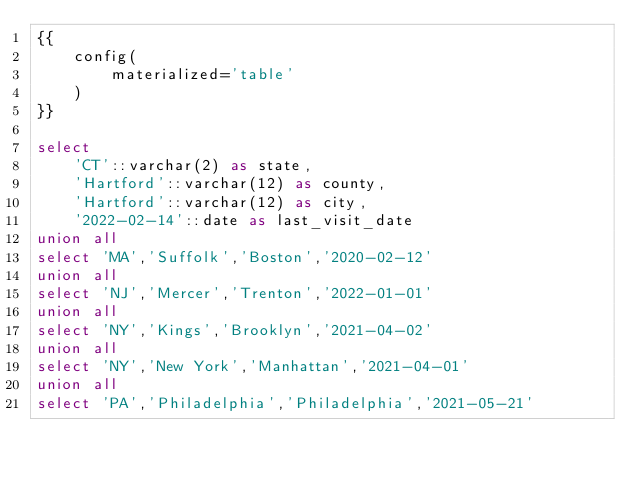<code> <loc_0><loc_0><loc_500><loc_500><_SQL_>{{
    config(
        materialized='table'
    )
}}

select
    'CT'::varchar(2) as state,
    'Hartford'::varchar(12) as county,
    'Hartford'::varchar(12) as city,
    '2022-02-14'::date as last_visit_date
union all
select 'MA','Suffolk','Boston','2020-02-12'
union all
select 'NJ','Mercer','Trenton','2022-01-01'
union all
select 'NY','Kings','Brooklyn','2021-04-02'
union all
select 'NY','New York','Manhattan','2021-04-01'
union all
select 'PA','Philadelphia','Philadelphia','2021-05-21'
</code> 